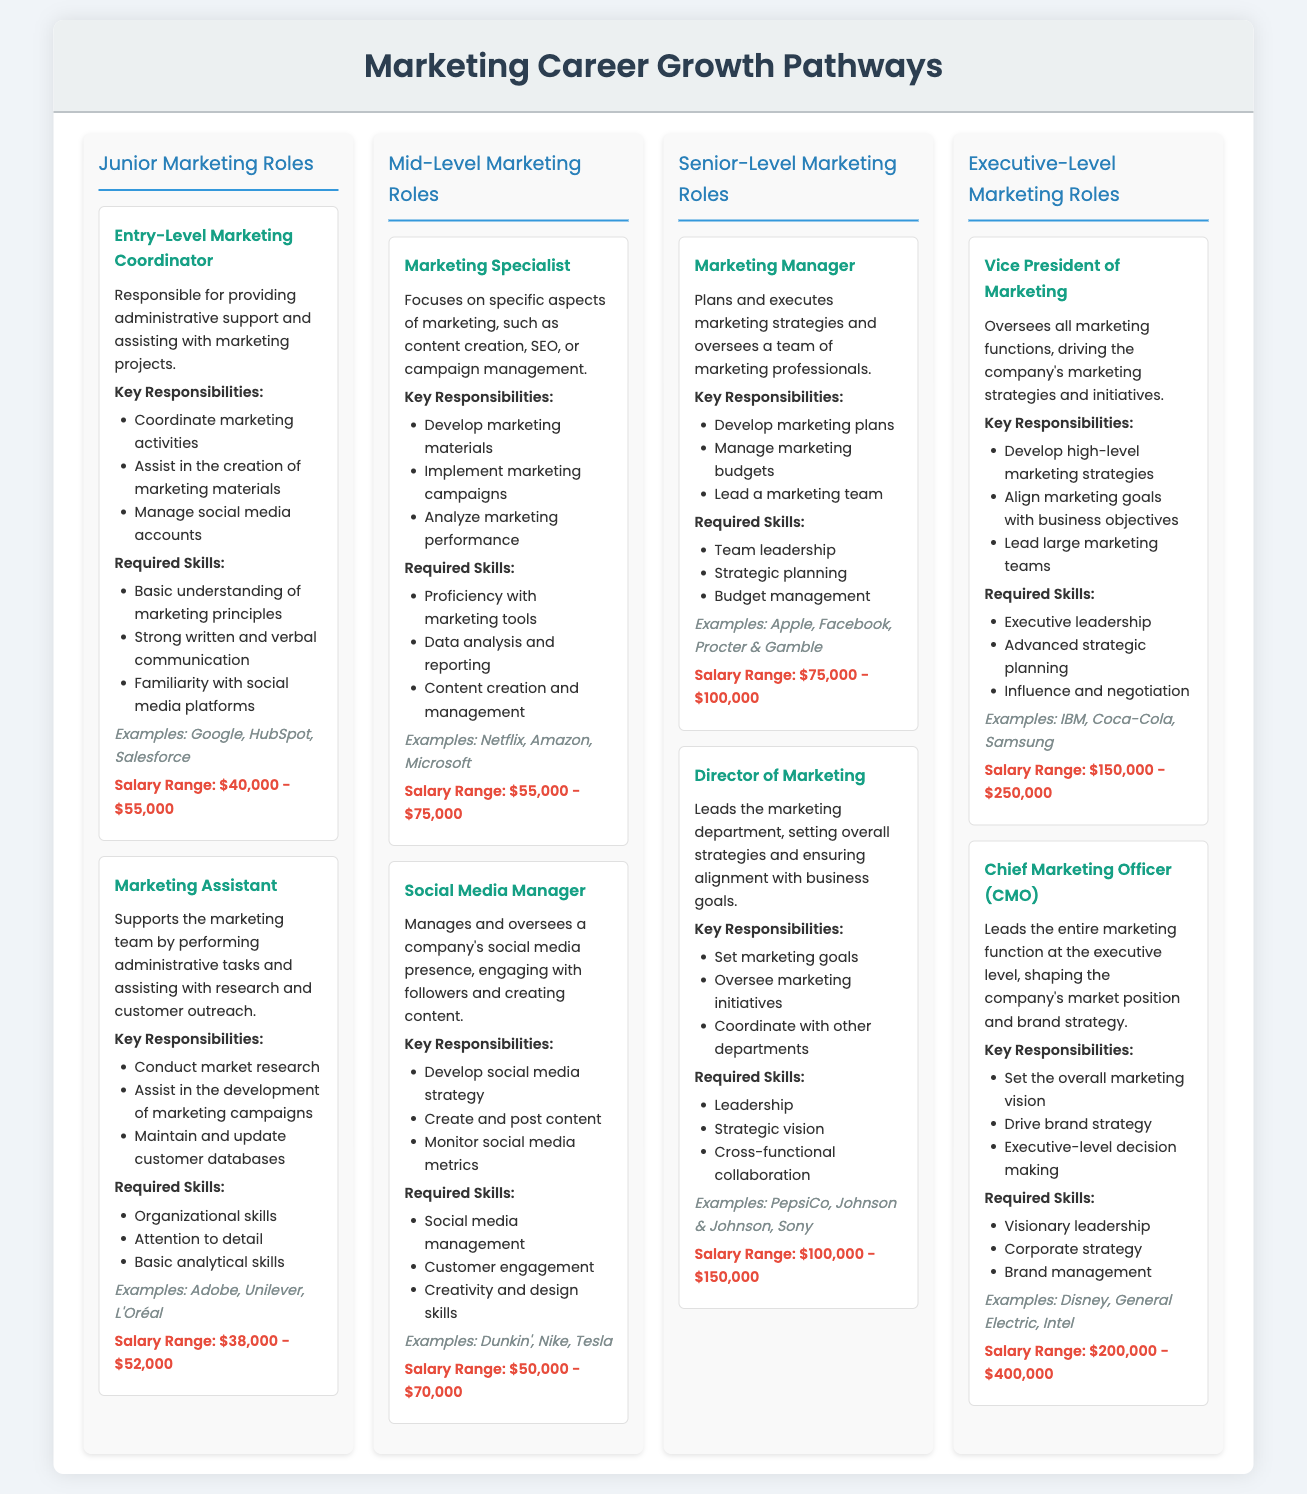What is the salary range for an Entry-Level Marketing Coordinator? The salary range for an Entry-Level Marketing Coordinator is stated in the document as $40,000 - $55,000.
Answer: $40,000 - $55,000 What are the required skills for a Marketing Specialist? The required skills for a Marketing Specialist include proficiency with marketing tools, data analysis and reporting, and content creation and management.
Answer: Proficiency with marketing tools, data analysis and reporting, content creation and management Which company is an example associated with the Social Media Manager role? The document lists Dunkin', Nike, and Tesla as examples for the Social Media Manager role.
Answer: Dunkin' What key responsibility is shared by both the Marketing Manager and the Director of Marketing? Both roles involve setting marketing strategies that align with business goals.
Answer: Setting marketing strategies that align with business goals How many senior-level marketing roles are listed in the document? The document lists two senior-level marketing roles: Marketing Manager and Director of Marketing.
Answer: Two Which role has the highest salary range in the document? The role with the highest salary range is the Chief Marketing Officer (CMO) with a range of $200,000 - $400,000.
Answer: Chief Marketing Officer (CMO) What type of document is this? The document is a hierarchical infographic representing marketing career growth pathways.
Answer: Hierarchical infographic What is one example of a company that might hire a Marketing Assistant? The document provides examples including Adobe, Unilever, and L'Oréal for a Marketing Assistant.
Answer: Adobe What is the primary focus of a Marketing Specialist? The primary focus of a Marketing Specialist is on specific aspects of marketing such as content creation, SEO, or campaign management.
Answer: Specific aspects of marketing such as content creation, SEO, or campaign management 